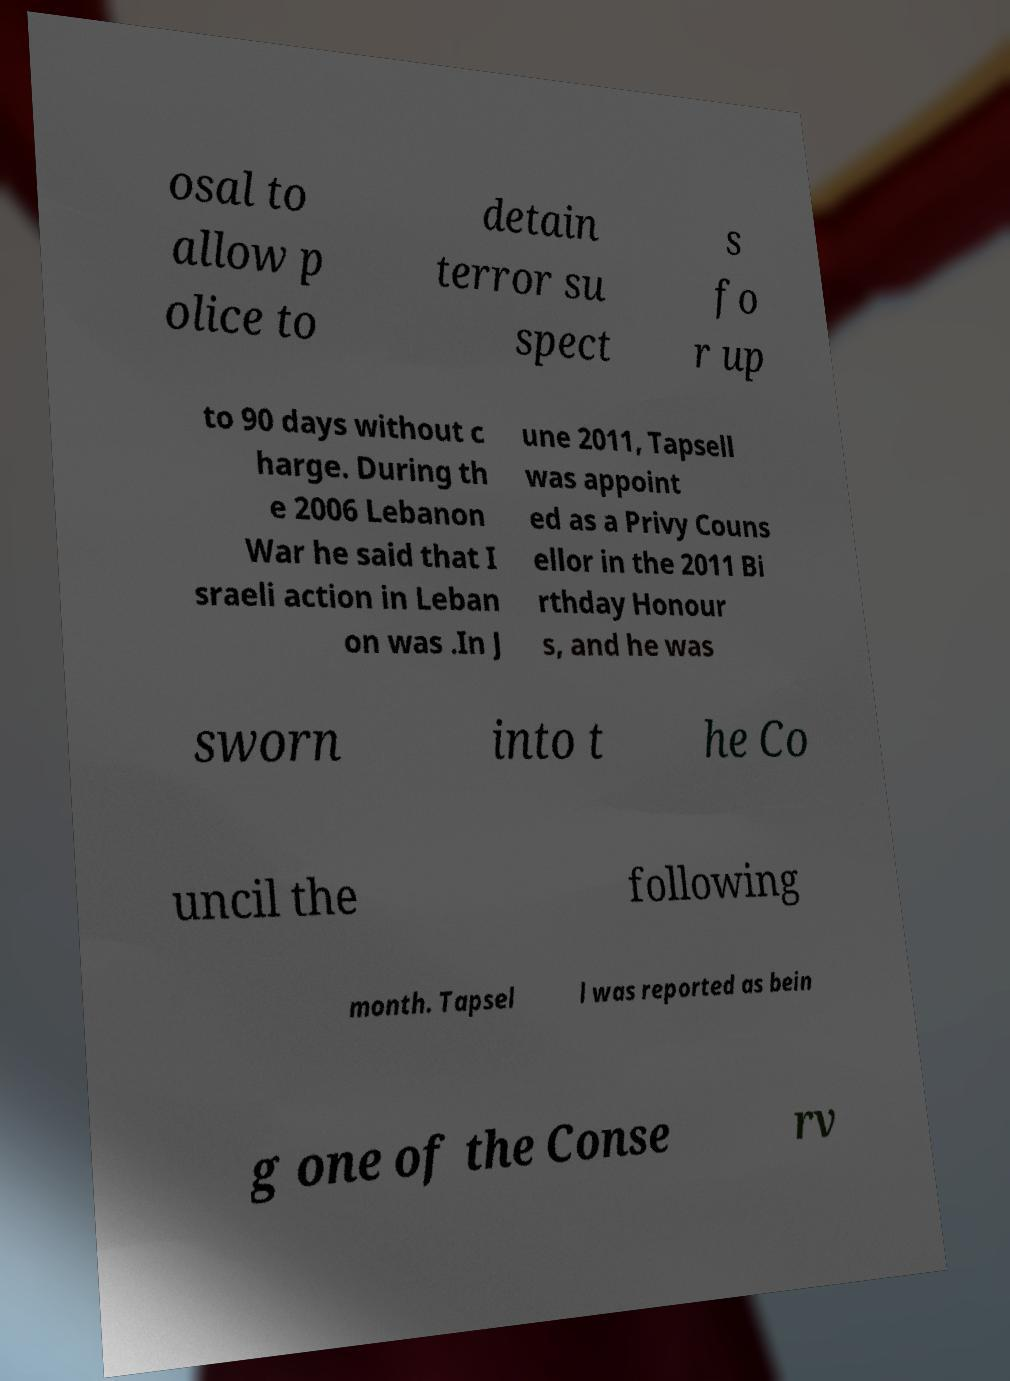Please identify and transcribe the text found in this image. osal to allow p olice to detain terror su spect s fo r up to 90 days without c harge. During th e 2006 Lebanon War he said that I sraeli action in Leban on was .In J une 2011, Tapsell was appoint ed as a Privy Couns ellor in the 2011 Bi rthday Honour s, and he was sworn into t he Co uncil the following month. Tapsel l was reported as bein g one of the Conse rv 